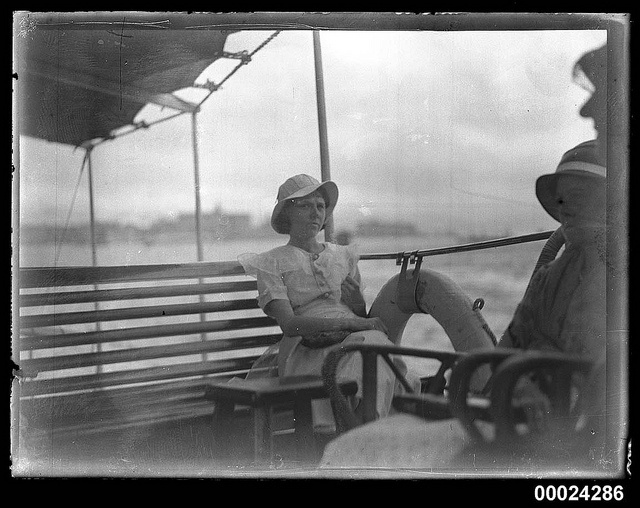Describe the objects in this image and their specific colors. I can see bench in black, gray, darkgray, and lightgray tones, people in black, gray, and lightgray tones, people in black, gray, and lightgray tones, people in black, gray, darkgray, and lightgray tones, and handbag in black tones in this image. 